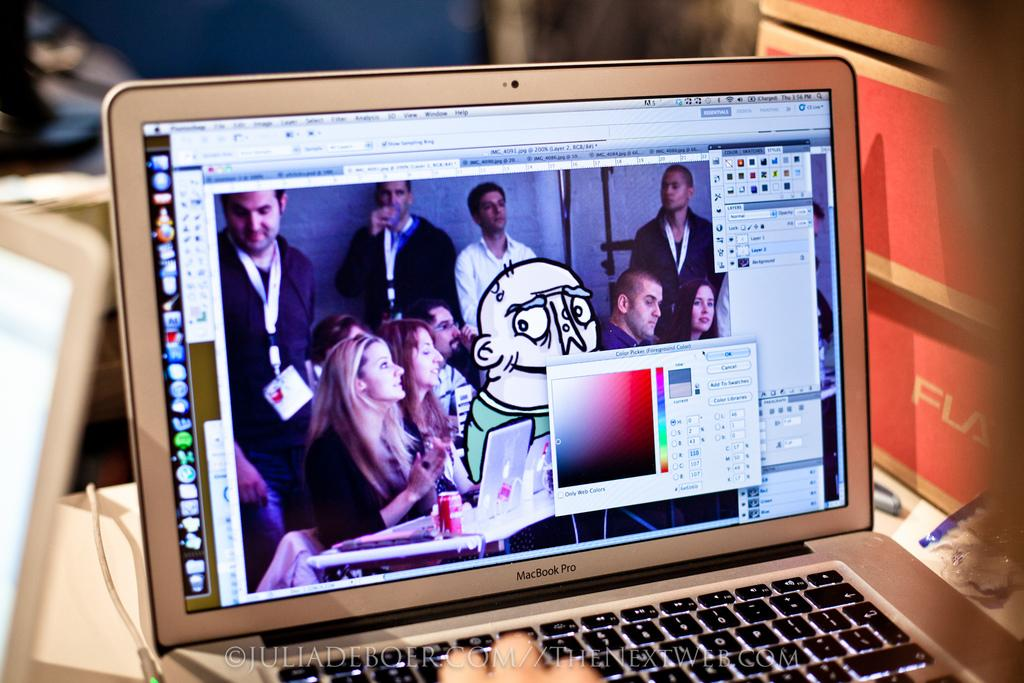<image>
Describe the image concisely. A grey MacBook Pro with content on it's monitor 